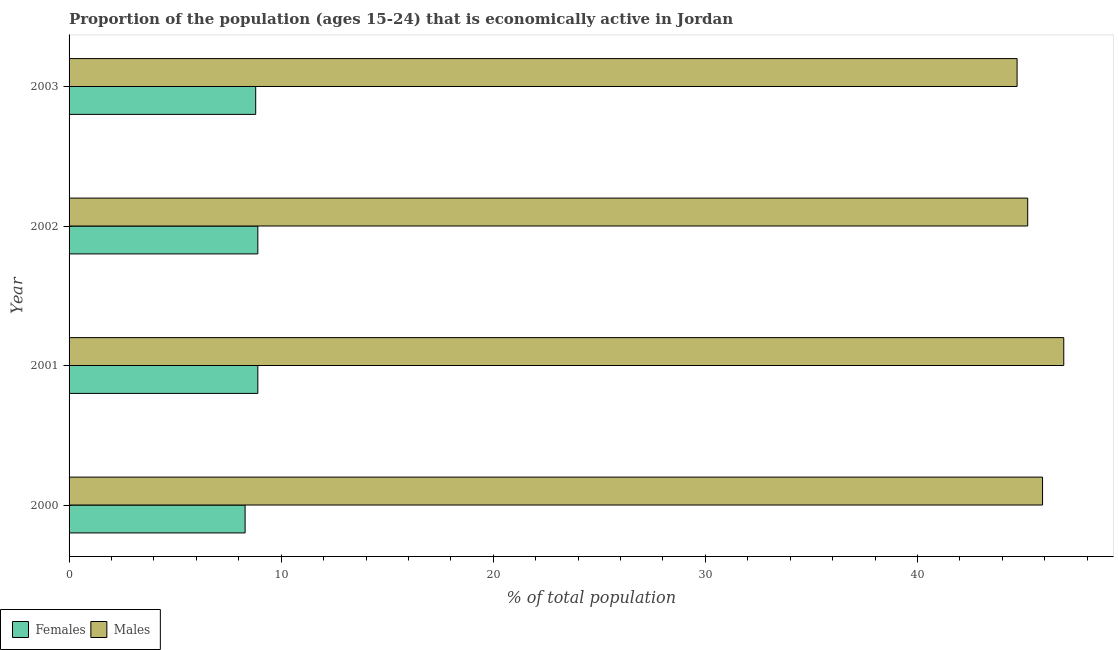How many bars are there on the 2nd tick from the top?
Offer a very short reply. 2. How many bars are there on the 3rd tick from the bottom?
Give a very brief answer. 2. In how many cases, is the number of bars for a given year not equal to the number of legend labels?
Your answer should be very brief. 0. What is the percentage of economically active female population in 2003?
Offer a terse response. 8.8. Across all years, what is the maximum percentage of economically active female population?
Make the answer very short. 8.9. Across all years, what is the minimum percentage of economically active female population?
Provide a short and direct response. 8.3. In which year was the percentage of economically active male population minimum?
Provide a short and direct response. 2003. What is the total percentage of economically active female population in the graph?
Your answer should be compact. 34.9. What is the difference between the percentage of economically active male population in 2003 and the percentage of economically active female population in 2001?
Your answer should be very brief. 35.8. What is the average percentage of economically active female population per year?
Offer a terse response. 8.72. In the year 2002, what is the difference between the percentage of economically active male population and percentage of economically active female population?
Give a very brief answer. 36.3. In how many years, is the percentage of economically active female population greater than 30 %?
Keep it short and to the point. 0. What is the ratio of the percentage of economically active female population in 2001 to that in 2002?
Provide a short and direct response. 1. What is the difference between the highest and the second highest percentage of economically active male population?
Offer a very short reply. 1. What does the 2nd bar from the top in 2003 represents?
Ensure brevity in your answer.  Females. What does the 2nd bar from the bottom in 2000 represents?
Your response must be concise. Males. How many years are there in the graph?
Offer a very short reply. 4. What is the difference between two consecutive major ticks on the X-axis?
Your answer should be very brief. 10. Does the graph contain any zero values?
Offer a terse response. No. What is the title of the graph?
Offer a very short reply. Proportion of the population (ages 15-24) that is economically active in Jordan. Does "2012 US$" appear as one of the legend labels in the graph?
Make the answer very short. No. What is the label or title of the X-axis?
Your response must be concise. % of total population. What is the label or title of the Y-axis?
Your answer should be compact. Year. What is the % of total population in Females in 2000?
Give a very brief answer. 8.3. What is the % of total population of Males in 2000?
Your answer should be very brief. 45.9. What is the % of total population in Females in 2001?
Give a very brief answer. 8.9. What is the % of total population of Males in 2001?
Your answer should be compact. 46.9. What is the % of total population of Females in 2002?
Ensure brevity in your answer.  8.9. What is the % of total population in Males in 2002?
Provide a succinct answer. 45.2. What is the % of total population in Females in 2003?
Ensure brevity in your answer.  8.8. What is the % of total population of Males in 2003?
Your answer should be compact. 44.7. Across all years, what is the maximum % of total population of Females?
Your answer should be very brief. 8.9. Across all years, what is the maximum % of total population of Males?
Your answer should be very brief. 46.9. Across all years, what is the minimum % of total population in Females?
Offer a very short reply. 8.3. Across all years, what is the minimum % of total population in Males?
Keep it short and to the point. 44.7. What is the total % of total population of Females in the graph?
Provide a short and direct response. 34.9. What is the total % of total population of Males in the graph?
Give a very brief answer. 182.7. What is the difference between the % of total population in Females in 2000 and that in 2001?
Provide a succinct answer. -0.6. What is the difference between the % of total population of Males in 2000 and that in 2001?
Provide a short and direct response. -1. What is the difference between the % of total population in Females in 2000 and that in 2002?
Give a very brief answer. -0.6. What is the difference between the % of total population in Females in 2000 and that in 2003?
Ensure brevity in your answer.  -0.5. What is the difference between the % of total population of Females in 2001 and that in 2002?
Your answer should be compact. 0. What is the difference between the % of total population of Males in 2002 and that in 2003?
Your answer should be very brief. 0.5. What is the difference between the % of total population of Females in 2000 and the % of total population of Males in 2001?
Your response must be concise. -38.6. What is the difference between the % of total population of Females in 2000 and the % of total population of Males in 2002?
Make the answer very short. -36.9. What is the difference between the % of total population in Females in 2000 and the % of total population in Males in 2003?
Your response must be concise. -36.4. What is the difference between the % of total population in Females in 2001 and the % of total population in Males in 2002?
Your answer should be very brief. -36.3. What is the difference between the % of total population of Females in 2001 and the % of total population of Males in 2003?
Offer a terse response. -35.8. What is the difference between the % of total population of Females in 2002 and the % of total population of Males in 2003?
Offer a very short reply. -35.8. What is the average % of total population in Females per year?
Provide a short and direct response. 8.72. What is the average % of total population in Males per year?
Ensure brevity in your answer.  45.67. In the year 2000, what is the difference between the % of total population in Females and % of total population in Males?
Your answer should be compact. -37.6. In the year 2001, what is the difference between the % of total population in Females and % of total population in Males?
Ensure brevity in your answer.  -38. In the year 2002, what is the difference between the % of total population in Females and % of total population in Males?
Your answer should be very brief. -36.3. In the year 2003, what is the difference between the % of total population in Females and % of total population in Males?
Offer a terse response. -35.9. What is the ratio of the % of total population in Females in 2000 to that in 2001?
Make the answer very short. 0.93. What is the ratio of the % of total population of Males in 2000 to that in 2001?
Ensure brevity in your answer.  0.98. What is the ratio of the % of total population in Females in 2000 to that in 2002?
Offer a very short reply. 0.93. What is the ratio of the % of total population in Males in 2000 to that in 2002?
Make the answer very short. 1.02. What is the ratio of the % of total population of Females in 2000 to that in 2003?
Offer a terse response. 0.94. What is the ratio of the % of total population in Males in 2000 to that in 2003?
Give a very brief answer. 1.03. What is the ratio of the % of total population of Females in 2001 to that in 2002?
Provide a short and direct response. 1. What is the ratio of the % of total population of Males in 2001 to that in 2002?
Your answer should be compact. 1.04. What is the ratio of the % of total population of Females in 2001 to that in 2003?
Your answer should be compact. 1.01. What is the ratio of the % of total population in Males in 2001 to that in 2003?
Ensure brevity in your answer.  1.05. What is the ratio of the % of total population in Females in 2002 to that in 2003?
Offer a very short reply. 1.01. What is the ratio of the % of total population of Males in 2002 to that in 2003?
Ensure brevity in your answer.  1.01. What is the difference between the highest and the second highest % of total population in Males?
Your answer should be very brief. 1. What is the difference between the highest and the lowest % of total population of Females?
Make the answer very short. 0.6. What is the difference between the highest and the lowest % of total population of Males?
Provide a short and direct response. 2.2. 